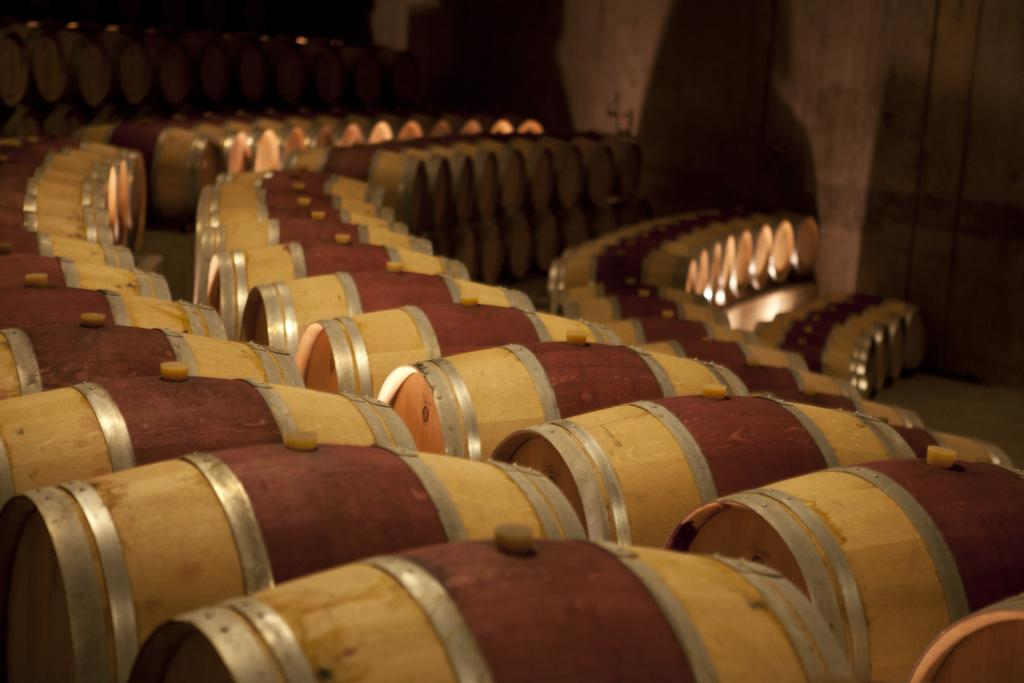What type of objects are present in the image? There are wooden barrels in the image. What can be seen beneath the wooden barrels? The ground is visible in the image. What type of play is happening in the image? There is no play or indication of play in the image; it features wooden barrels and the ground. What is the purpose of the wooden barrels in the image? The purpose of the wooden barrels cannot be determined from the image alone, as their function or intended use is not evident. 